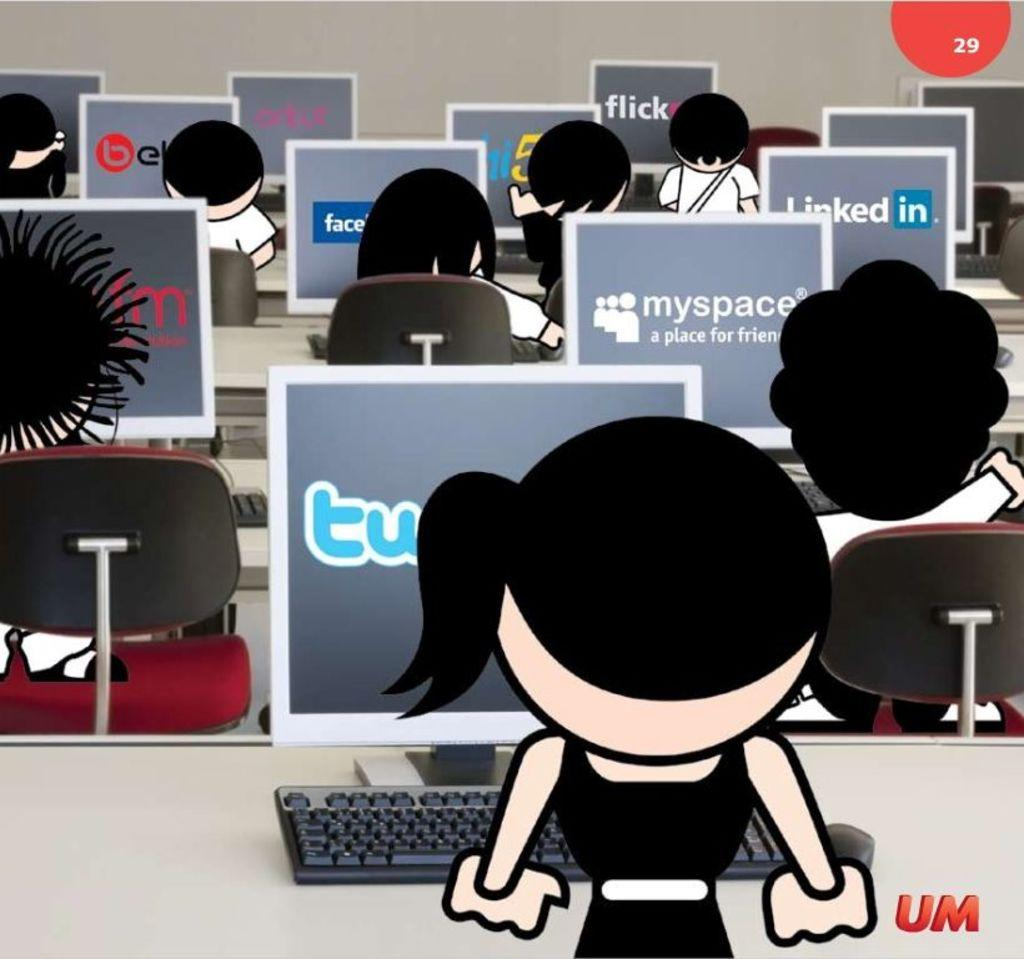What type of image is being described? The image is animated. What can be seen within the animated image? There are systems and chairs in the image. Are there any people present in the image? Yes, there are persons in the image. How much glue is needed to fix the account in the image? There is no mention of glue, accounts, or any need for fixing in the image. 